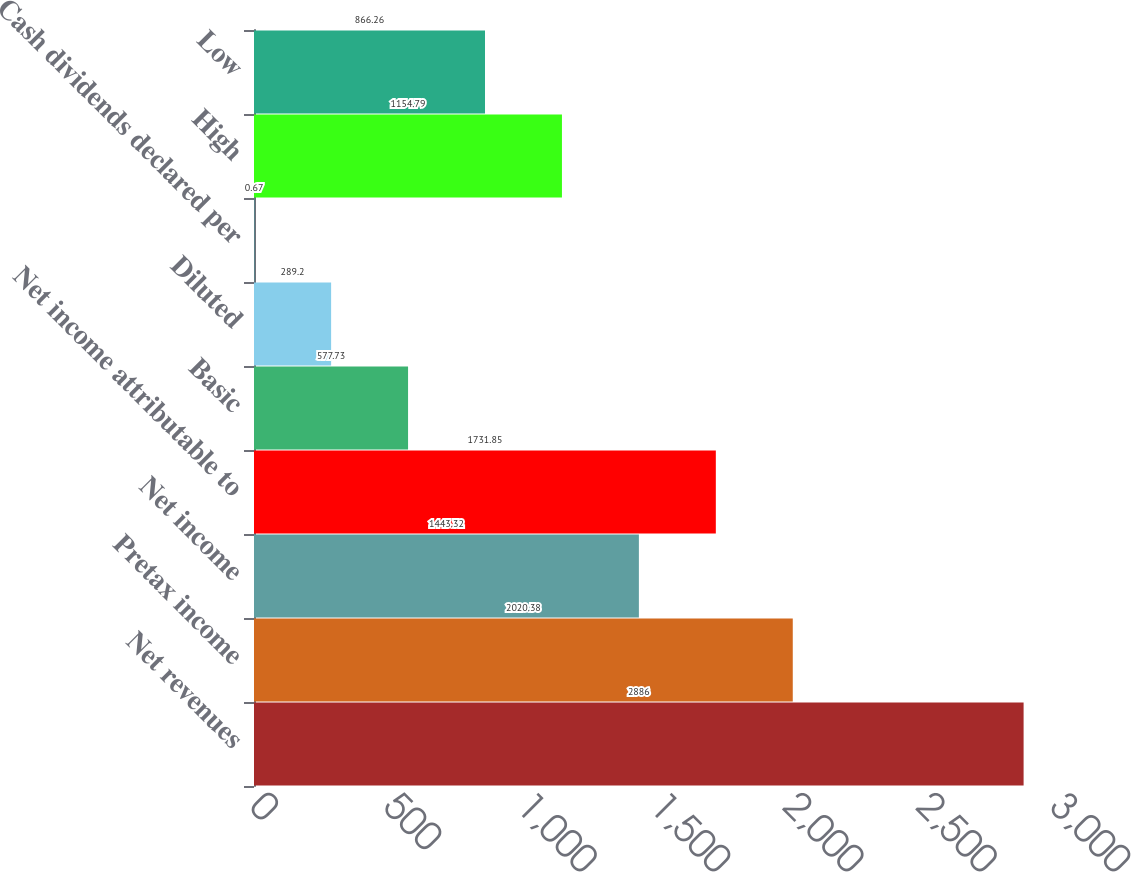Convert chart. <chart><loc_0><loc_0><loc_500><loc_500><bar_chart><fcel>Net revenues<fcel>Pretax income<fcel>Net income<fcel>Net income attributable to<fcel>Basic<fcel>Diluted<fcel>Cash dividends declared per<fcel>High<fcel>Low<nl><fcel>2886<fcel>2020.38<fcel>1443.32<fcel>1731.85<fcel>577.73<fcel>289.2<fcel>0.67<fcel>1154.79<fcel>866.26<nl></chart> 